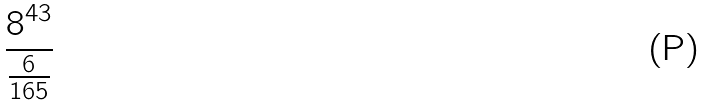Convert formula to latex. <formula><loc_0><loc_0><loc_500><loc_500>\frac { 8 ^ { 4 3 } } { \frac { 6 } { 1 6 5 } }</formula> 